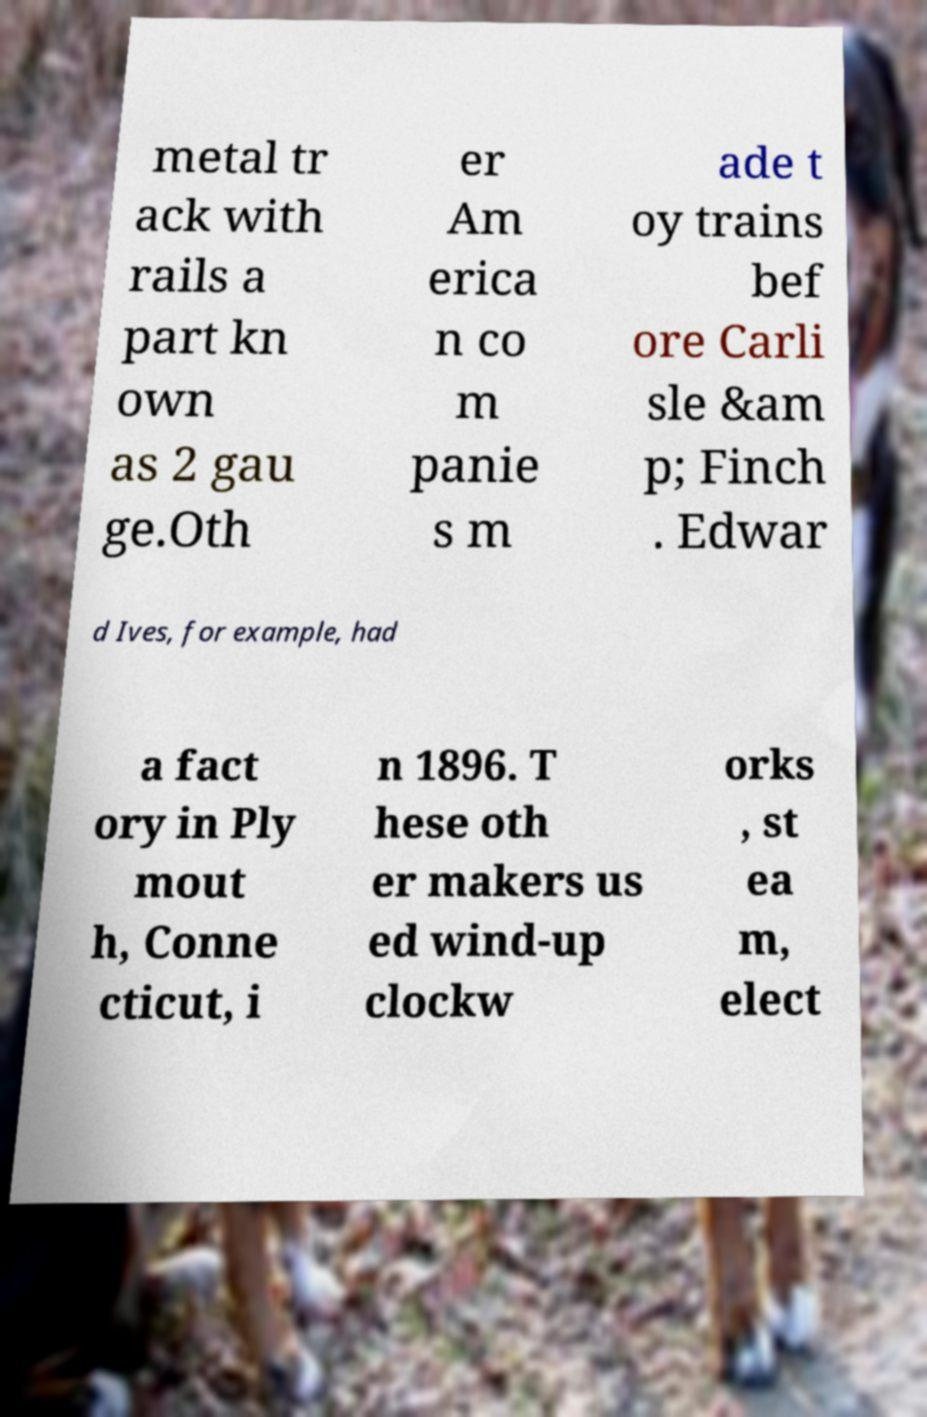Can you accurately transcribe the text from the provided image for me? metal tr ack with rails a part kn own as 2 gau ge.Oth er Am erica n co m panie s m ade t oy trains bef ore Carli sle &am p; Finch . Edwar d Ives, for example, had a fact ory in Ply mout h, Conne cticut, i n 1896. T hese oth er makers us ed wind-up clockw orks , st ea m, elect 